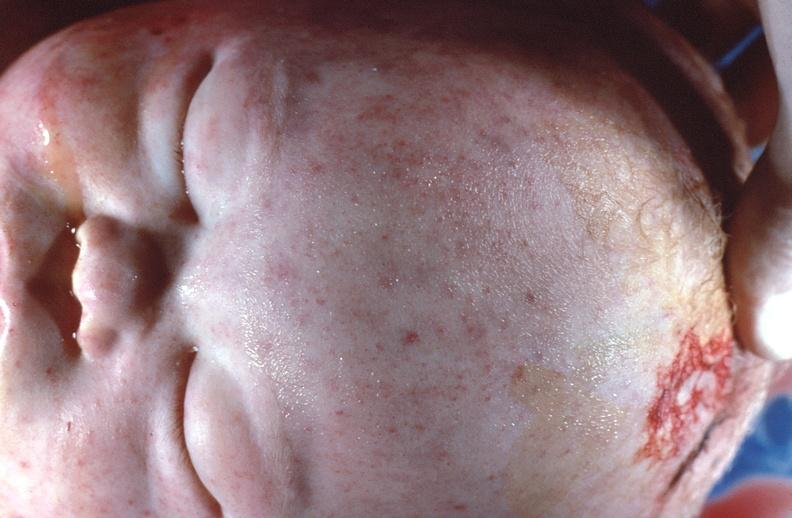what does this image show?
Answer the question using a single word or phrase. Gram negative septicemia due to scalp electrode in a neonate 